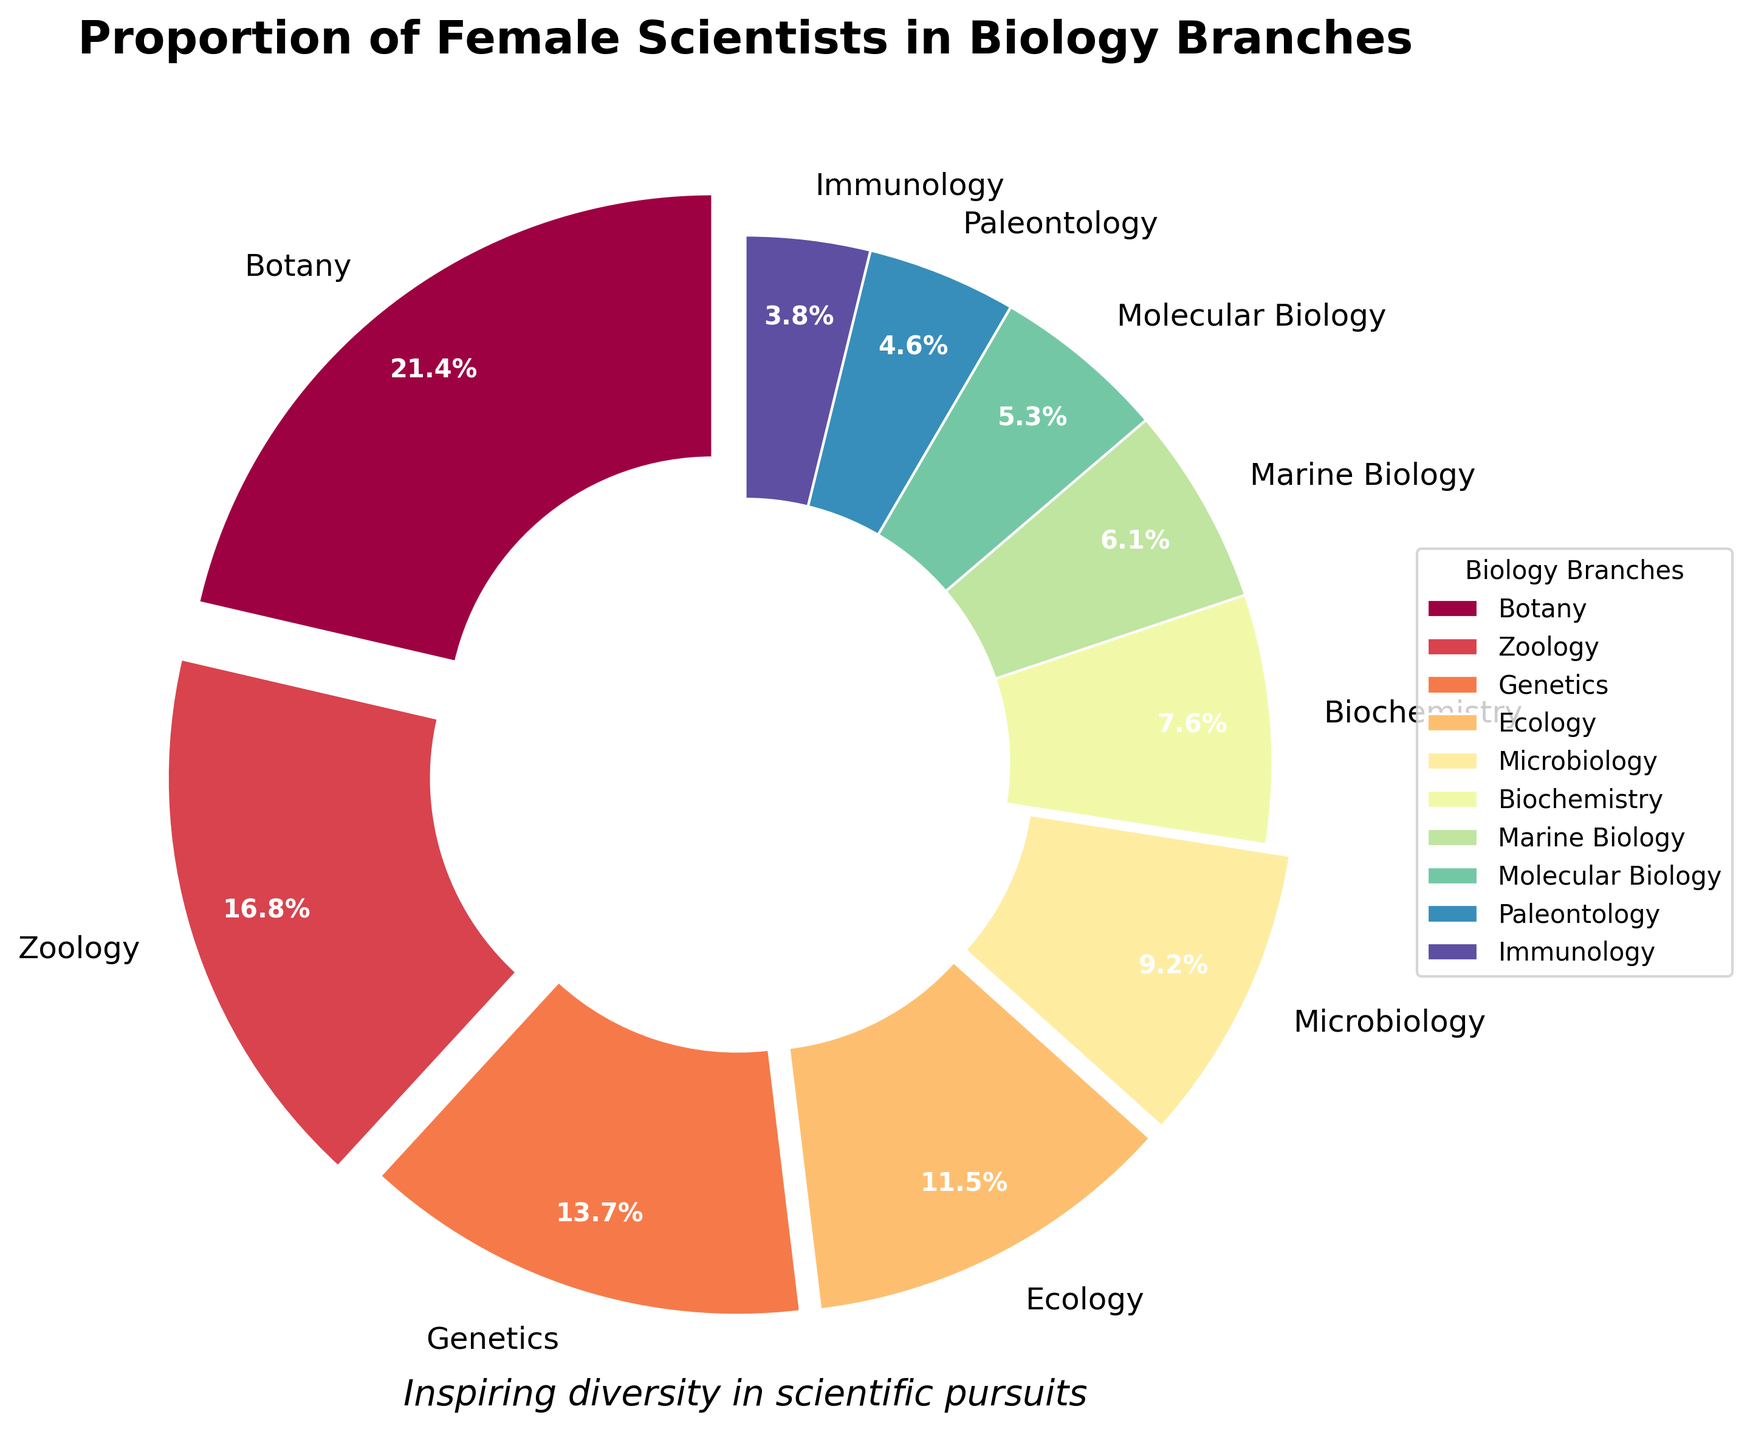What proportion of female scientists are in Botany? The pie chart shows the proportion of female scientists in different branches of biology. The section representing Botany is labeled with its percentage.
Answer: 28% Which branch has the second highest proportion of female scientists? The pie chart shows various segments labeled with percentages. Botany has the highest percentage, and the next largest segment is Zoology.
Answer: Zoology What is the combined percentage of female scientists in Genetics and Ecology? Refer to the pie chart to find the percentages for Genetics and Ecology. Add the two percentages together. Genetics is 18% and Ecology is 15%, so 18 + 15 = 33.
Answer: 33% Which branches have less than 10% of female scientists? Look at the pie chart for segments labeled with percentages less than 10%. These branches are Marine Biology, Molecular Biology, Paleontology, and Immunology.
Answer: Marine Biology, Molecular Biology, Paleontology, Immunology Is the proportion of female scientists in Microbiology higher or lower than in Biochemistry? Compare the percentages in the pie chart. Microbiology is 12% and Biochemistry is 10%. Microbiology has a higher percentage.
Answer: Higher What is the average percentage of female scientists across all the branches shown in the chart? Add all the percentages together and divide by the number of branches. The total is 28 + 22 + 18 + 15 + 12 + 10 + 8 + 7 + 6 + 5 = 131. There are 10 branches, so the average is 131 / 10 = 13.1%.
Answer: 13.1% How does the proportion of female scientists in Zoology compare to the sum of those in Biochemistry and Microbiology? Zoology has 22%. Biochemistry and Microbiology together have 10% + 12% = 22%. The proportions are equal.
Answer: Equal What is the difference in the proportion of female scientists between the largest and smallest segments? The largest segment is Botany with 28%, and the smallest is Immunology with 5%. The difference is 28 - 5 = 23.
Answer: 23% Which segment has the darkest shade, and what branch does it represent? The pie chart uses different colors, the darkest shade is visually distinguishable and represents the segment with the highest proportion. Botany is the largest segment and typically the darkest shade.
Answer: Botany Based on the chart, which branch should be targeted for initiatives to improve female participation given its current low representation? Look at the branches with the smallest percentages. Immunology has the lowest representation of female scientists at 5%, making it a prime candidate for initiatives.
Answer: Immunology 